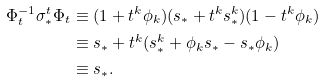<formula> <loc_0><loc_0><loc_500><loc_500>\Phi ^ { - 1 } _ { t } \sigma ^ { t } _ { * } \Phi _ { t } & \equiv ( 1 + t ^ { k } \phi _ { k } ) ( s _ { * } + t ^ { k } s ^ { k } _ { * } ) ( 1 - t ^ { k } \phi _ { k } ) \\ & \equiv s _ { * } + t ^ { k } ( s ^ { k } _ { * } + \phi _ { k } s _ { * } - s _ { * } \phi _ { k } ) \\ & \equiv s _ { * } .</formula> 